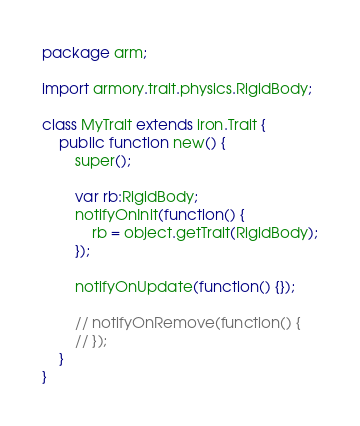Convert code to text. <code><loc_0><loc_0><loc_500><loc_500><_Haxe_>package arm;

import armory.trait.physics.RigidBody;

class MyTrait extends iron.Trait {
	public function new() {
		super();

		var rb:RigidBody;
		notifyOnInit(function() {
			rb = object.getTrait(RigidBody);
		});

		notifyOnUpdate(function() {});

		// notifyOnRemove(function() {
		// });
	}
}
</code> 